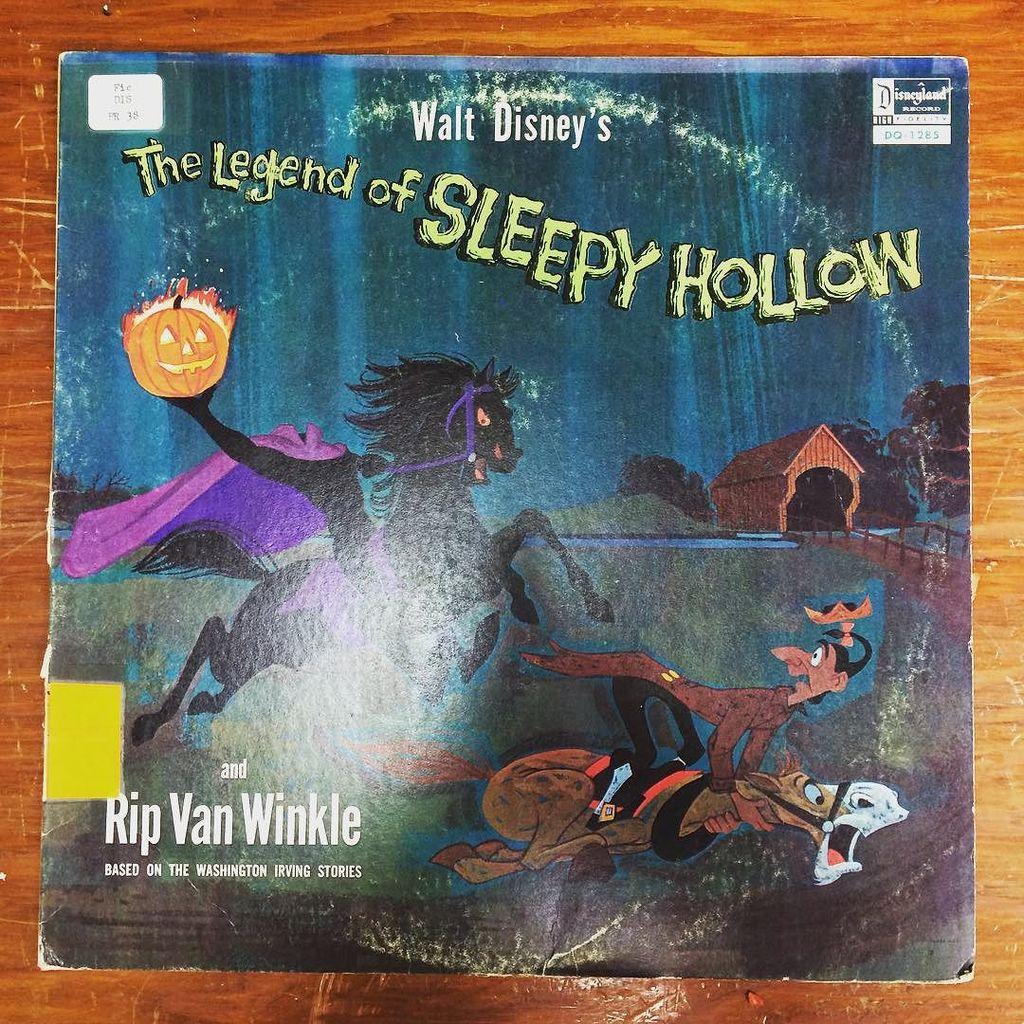What author's stories is this book based on?
Keep it short and to the point. Washington irving. What legends is this book about?
Give a very brief answer. Sleepy hollow. 